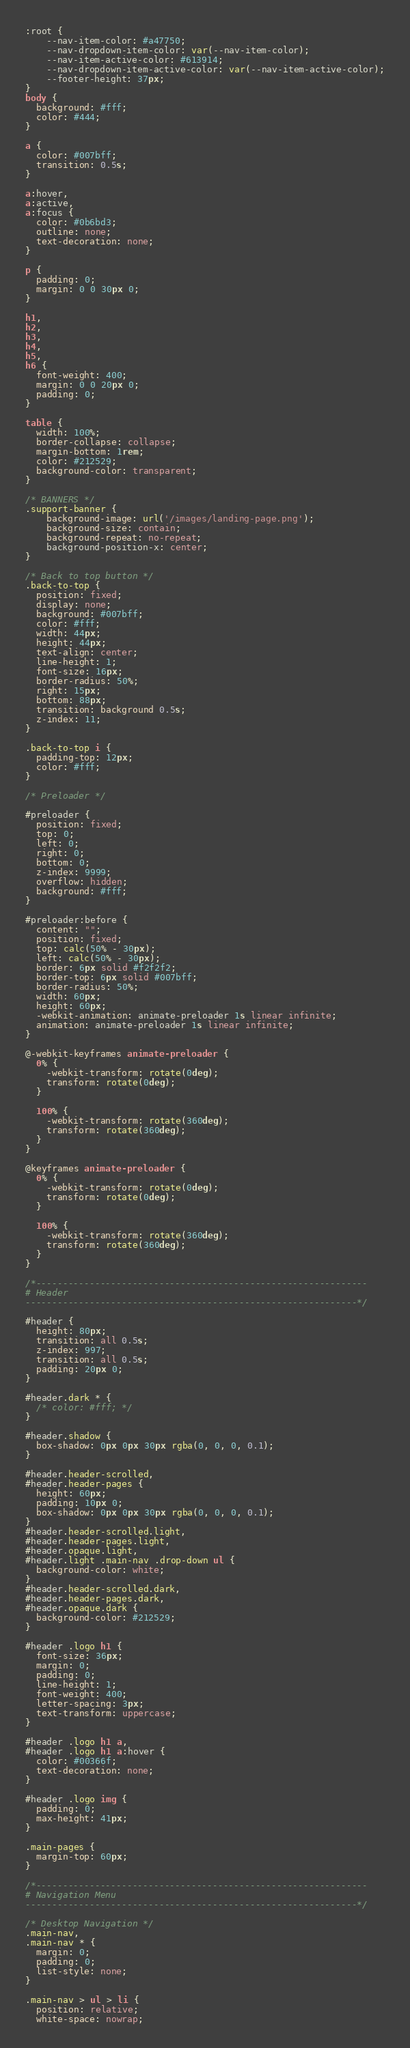<code> <loc_0><loc_0><loc_500><loc_500><_CSS_>:root {
    --nav-item-color: #a47750;
    --nav-dropdown-item-color: var(--nav-item-color);
    --nav-item-active-color: #613914;
    --nav-dropdown-item-active-color: var(--nav-item-active-color);
    --footer-height: 37px;
}
body {
  background: #fff;
  color: #444;
}

a {
  color: #007bff;
  transition: 0.5s;
}

a:hover,
a:active,
a:focus {
  color: #0b6bd3;
  outline: none;
  text-decoration: none;
}

p {
  padding: 0;
  margin: 0 0 30px 0;
}

h1,
h2,
h3,
h4,
h5,
h6 {
  font-weight: 400;
  margin: 0 0 20px 0;
  padding: 0;
}

table {
  width: 100%;
  border-collapse: collapse;
  margin-bottom: 1rem;
  color: #212529;
  background-color: transparent;
}

/* BANNERS */
.support-banner {
    background-image: url('/images/landing-page.png'); 
    background-size: contain;
    background-repeat: no-repeat;
    background-position-x: center;
}

/* Back to top button */
.back-to-top {
  position: fixed;
  display: none;
  background: #007bff;
  color: #fff;
  width: 44px;
  height: 44px;
  text-align: center;
  line-height: 1;
  font-size: 16px;
  border-radius: 50%;
  right: 15px;
  bottom: 88px;
  transition: background 0.5s;
  z-index: 11;
}

.back-to-top i {
  padding-top: 12px;
  color: #fff;
}

/* Preloader */

#preloader {
  position: fixed;
  top: 0;
  left: 0;
  right: 0;
  bottom: 0;
  z-index: 9999;
  overflow: hidden;
  background: #fff;
}

#preloader:before {
  content: "";
  position: fixed;
  top: calc(50% - 30px);
  left: calc(50% - 30px);
  border: 6px solid #f2f2f2;
  border-top: 6px solid #007bff;
  border-radius: 50%;
  width: 60px;
  height: 60px;
  -webkit-animation: animate-preloader 1s linear infinite;
  animation: animate-preloader 1s linear infinite;
}

@-webkit-keyframes animate-preloader {
  0% {
    -webkit-transform: rotate(0deg);
    transform: rotate(0deg);
  }

  100% {
    -webkit-transform: rotate(360deg);
    transform: rotate(360deg);
  }
}

@keyframes animate-preloader {
  0% {
    -webkit-transform: rotate(0deg);
    transform: rotate(0deg);
  }

  100% {
    -webkit-transform: rotate(360deg);
    transform: rotate(360deg);
  }
}

/*--------------------------------------------------------------
# Header
--------------------------------------------------------------*/

#header {
  height: 80px;
  transition: all 0.5s;
  z-index: 997;
  transition: all 0.5s;
  padding: 20px 0;
}

#header.dark * {
  /* color: #fff; */
}

#header.shadow {
  box-shadow: 0px 0px 30px rgba(0, 0, 0, 0.1);
}

#header.header-scrolled,
#header.header-pages {
  height: 60px;
  padding: 10px 0;
  box-shadow: 0px 0px 30px rgba(0, 0, 0, 0.1);
}
#header.header-scrolled.light,
#header.header-pages.light,
#header.opaque.light,
#header.light .main-nav .drop-down ul {
  background-color: white;
}
#header.header-scrolled.dark,
#header.header-pages.dark,
#header.opaque.dark {
  background-color: #212529;
}

#header .logo h1 {
  font-size: 36px;
  margin: 0;
  padding: 0;
  line-height: 1;
  font-weight: 400;
  letter-spacing: 3px;
  text-transform: uppercase;
}

#header .logo h1 a,
#header .logo h1 a:hover {
  color: #00366f;
  text-decoration: none;
}

#header .logo img {
  padding: 0;
  max-height: 41px;
}

.main-pages {
  margin-top: 60px;
}

/*--------------------------------------------------------------
# Navigation Menu
--------------------------------------------------------------*/

/* Desktop Navigation */
.main-nav,
.main-nav * {
  margin: 0;
  padding: 0;
  list-style: none;
}

.main-nav > ul > li {
  position: relative;
  white-space: nowrap;</code> 